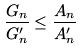Convert formula to latex. <formula><loc_0><loc_0><loc_500><loc_500>\frac { G _ { n } } { G _ { n } ^ { \prime } } \leq \frac { A _ { n } } { A _ { n } ^ { \prime } }</formula> 